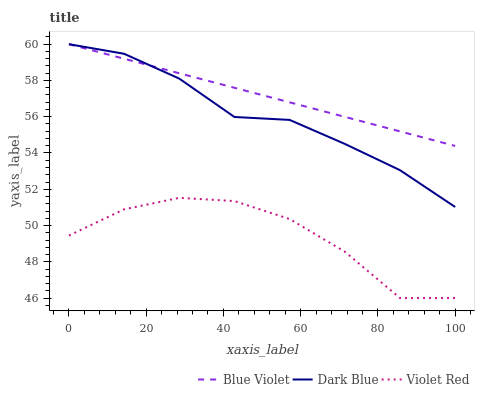Does Blue Violet have the minimum area under the curve?
Answer yes or no. No. Does Violet Red have the maximum area under the curve?
Answer yes or no. No. Is Violet Red the smoothest?
Answer yes or no. No. Is Blue Violet the roughest?
Answer yes or no. No. Does Blue Violet have the lowest value?
Answer yes or no. No. Does Violet Red have the highest value?
Answer yes or no. No. Is Violet Red less than Blue Violet?
Answer yes or no. Yes. Is Dark Blue greater than Violet Red?
Answer yes or no. Yes. Does Violet Red intersect Blue Violet?
Answer yes or no. No. 